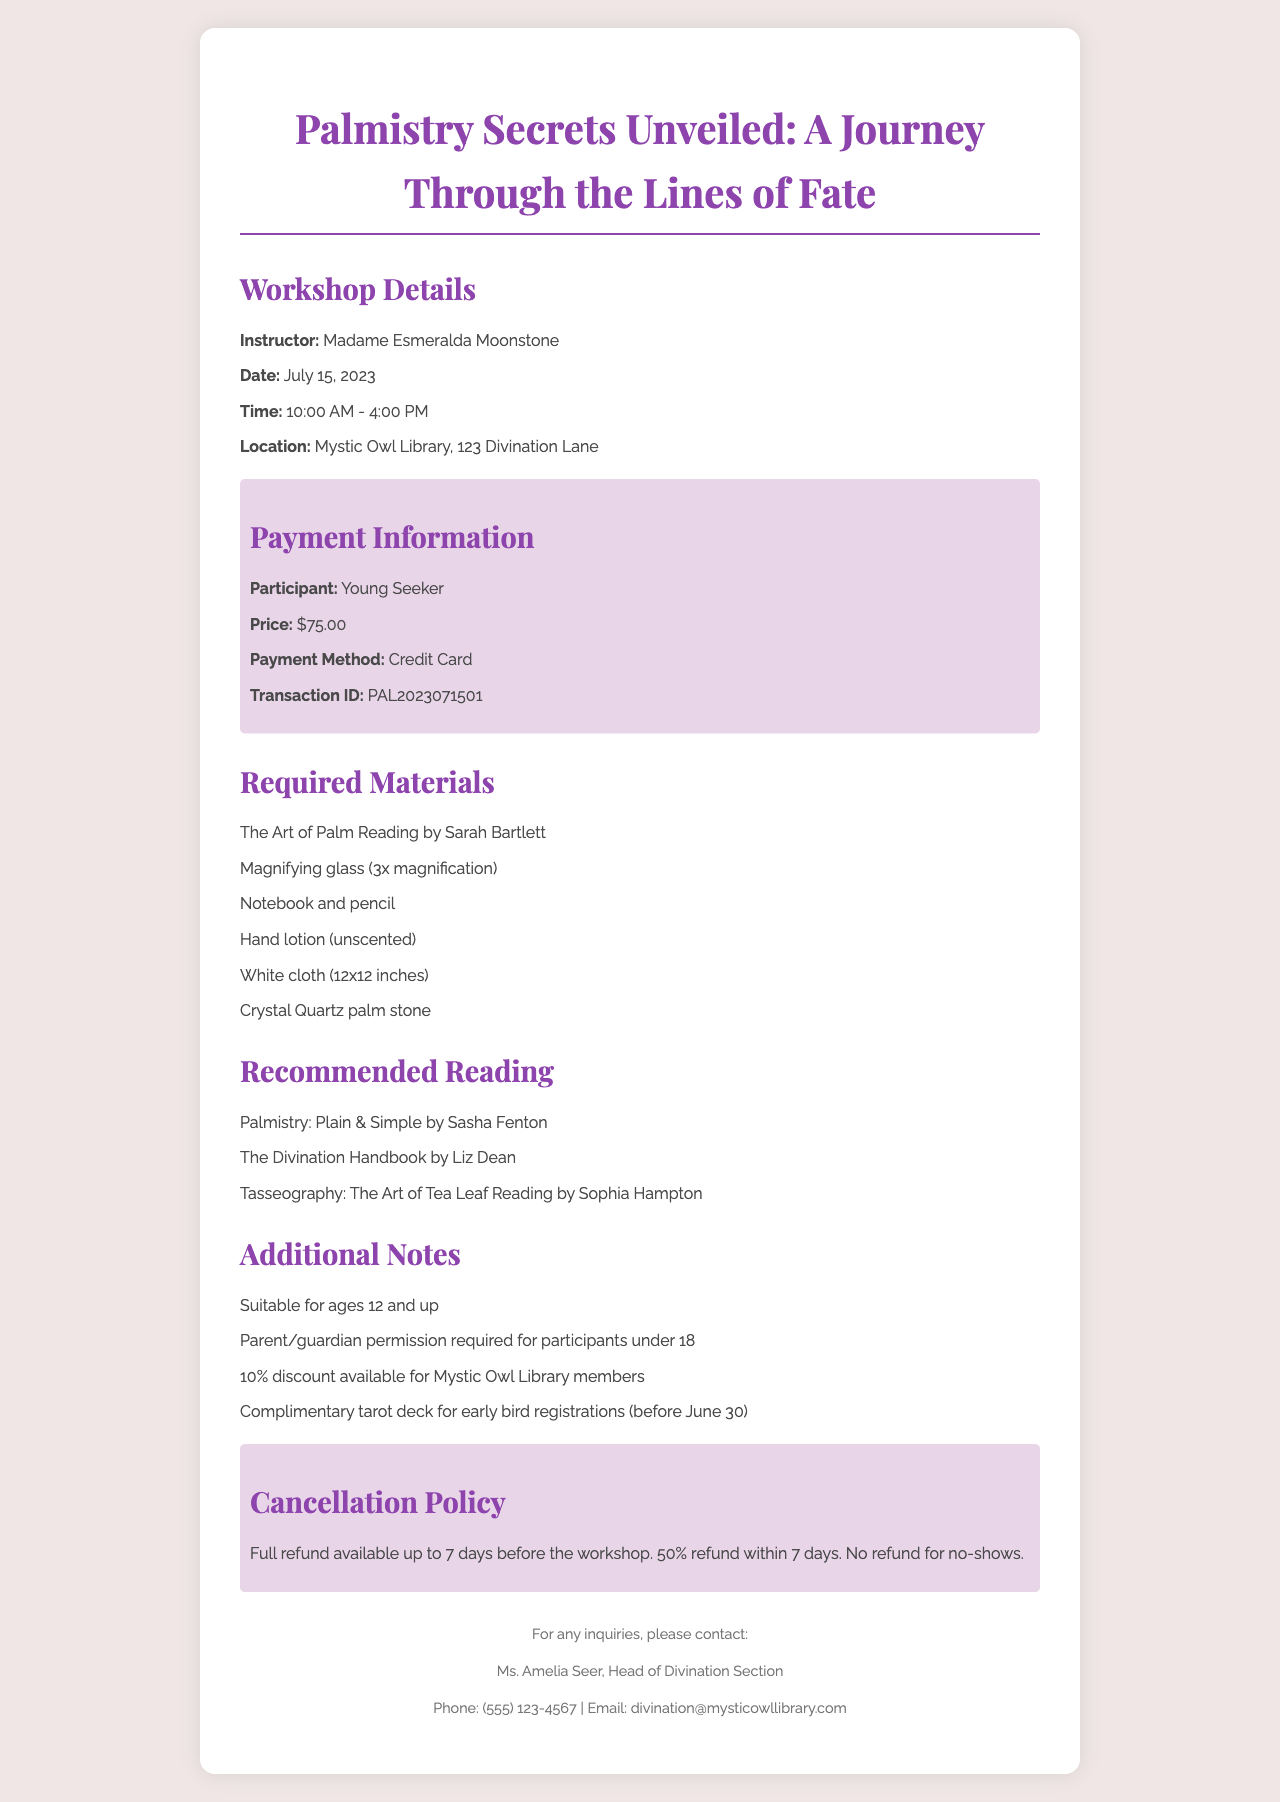What is the name of the workshop? The workshop name is clearly stated in the document and is "Palmistry Secrets Unveiled: A Journey Through the Lines of Fate."
Answer: Palmistry Secrets Unveiled: A Journey Through the Lines of Fate Who is the instructor for the workshop? The document lists Madame Esmeralda Moonstone as the instructor for the workshop.
Answer: Madame Esmeralda Moonstone What is the price of the workshop? The price mentioned in the receipt for the workshop is $75.00.
Answer: $75.00 On what date is the workshop scheduled? The date for the workshop is provided and is July 15, 2023.
Answer: July 15, 2023 What materials are required for the workshop? The document includes a list of required materials, which includes items like "The Art of Palm Reading by Sarah Bartlett."
Answer: The Art of Palm Reading by Sarah Bartlett, Magnifying glass (3x magnification), Notebook and pencil, Hand lotion (unscented), White cloth (12x12 inches), Crystal Quartz palm stone How long is the duration of the workshop? The time stated in the document indicates that the workshop runs from 10:00 AM to 4:00 PM, which means it lasts for a total of 6 hours.
Answer: 6 hours What is the cancellation policy for the workshop? The document explains the cancellation policy, which provides details about refund eligibility and conditions for cancellations.
Answer: Full refund available up to 7 days before the workshop Who should be contacted for inquiries? The librarian contact listed in the document is Ms. Amelia Seer, who heads the Divination Section.
Answer: Ms. Amelia Seer Is there a discount for library members? The additional notes indicate a 10% discount is available for Mystic Owl Library members.
Answer: 10% discount available for Mystic Owl Library members 